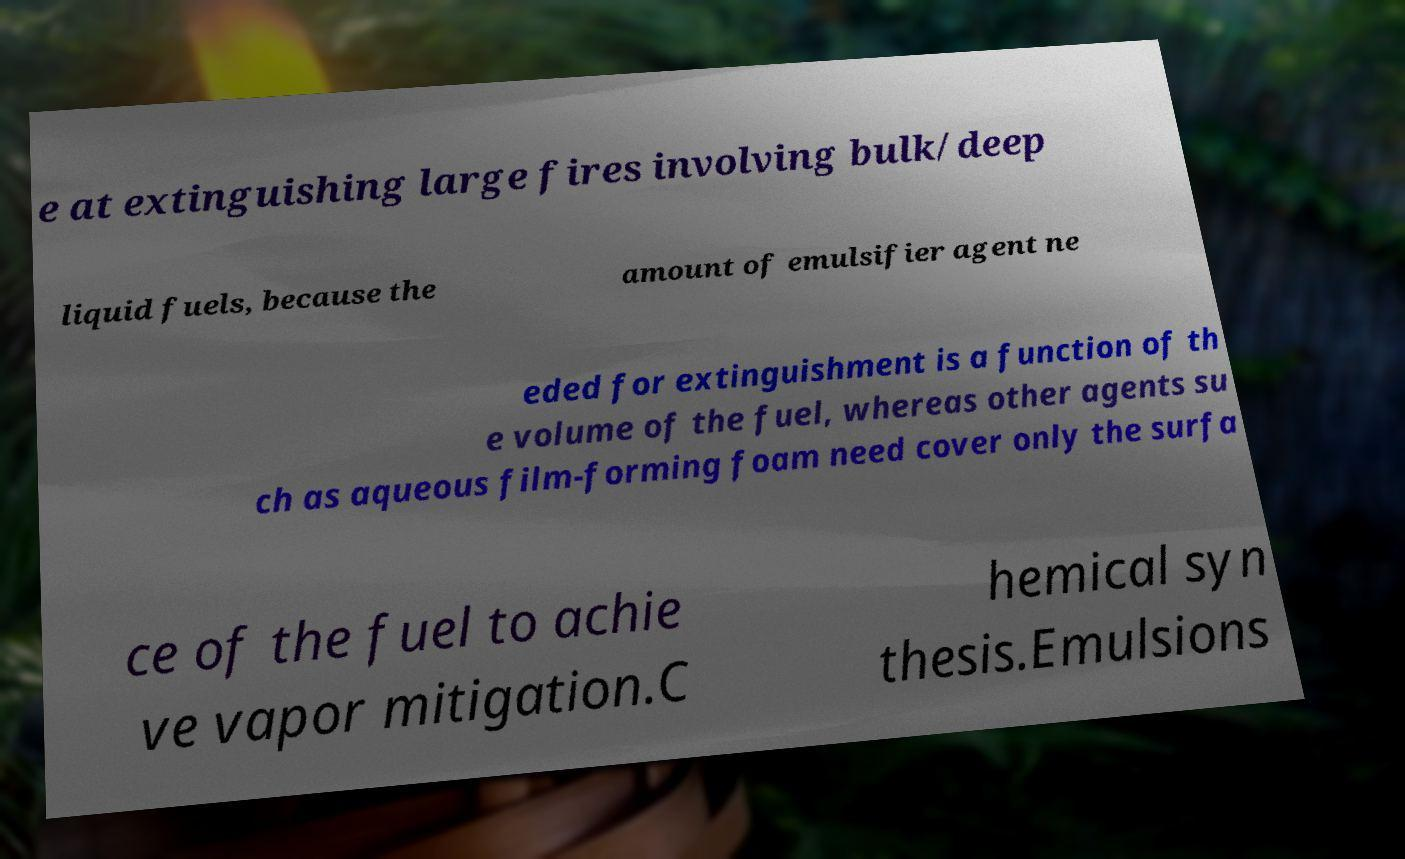Please identify and transcribe the text found in this image. e at extinguishing large fires involving bulk/deep liquid fuels, because the amount of emulsifier agent ne eded for extinguishment is a function of th e volume of the fuel, whereas other agents su ch as aqueous film-forming foam need cover only the surfa ce of the fuel to achie ve vapor mitigation.C hemical syn thesis.Emulsions 